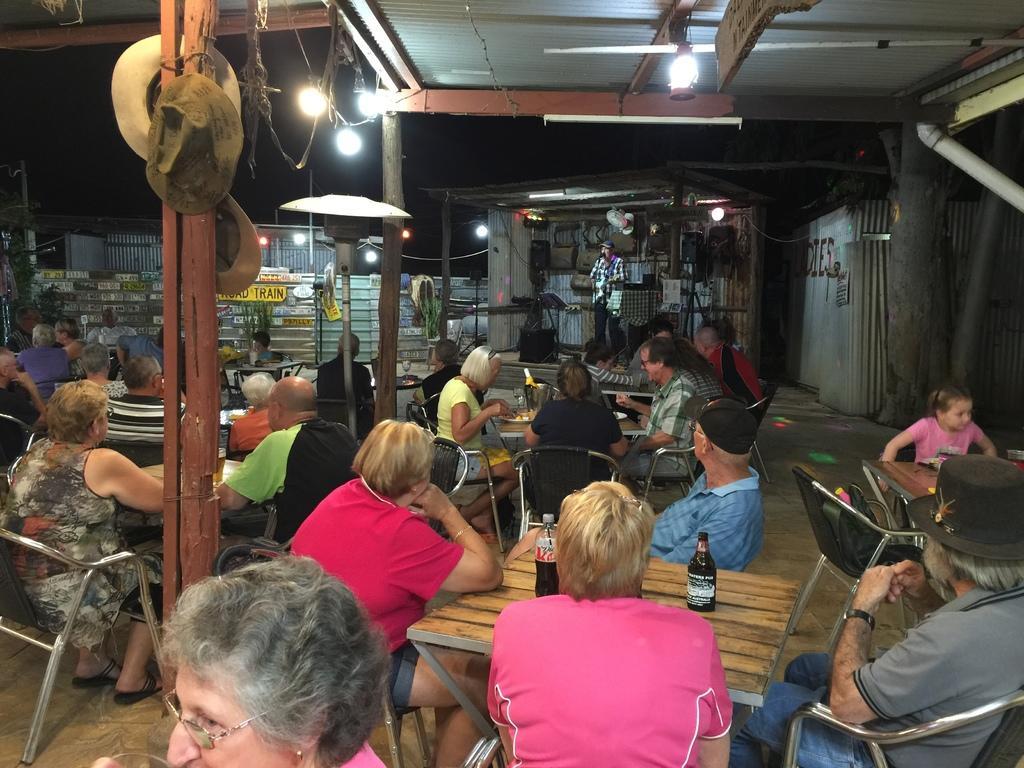In one or two sentences, can you explain what this image depicts? In this image I see number of people in which most of them are sitting on chairs and there are tables in front of them on which there are few things and I see a person over here who is standing and I see the lights and I see hats on this wooden pole and I see few more wooden poles and I see the wall over here. In the background it is dark and I see something is written over here. 